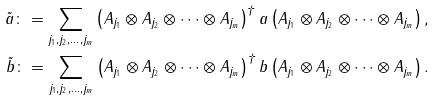Convert formula to latex. <formula><loc_0><loc_0><loc_500><loc_500>\tilde { a } \colon = \sum _ { j _ { 1 } , j _ { 2 } , \dots , j _ { m } } \left ( A _ { j _ { 1 } } \otimes A _ { j _ { 2 } } \otimes \cdots \otimes A _ { j _ { m } } \right ) ^ { \dag } a \left ( A _ { j _ { 1 } } \otimes A _ { j _ { 2 } } \otimes \cdots \otimes A _ { j _ { m } } \right ) , \\ \tilde { b } \colon = \sum _ { j _ { 1 } , j _ { 2 } , \dots , j _ { m } } \left ( A _ { j _ { 1 } } \otimes A _ { j _ { 2 } } \otimes \cdots \otimes A _ { j _ { m } } \right ) ^ { \dag } b \left ( A _ { j _ { 1 } } \otimes A _ { j _ { 2 } } \otimes \cdots \otimes A _ { j _ { m } } \right ) . \\</formula> 